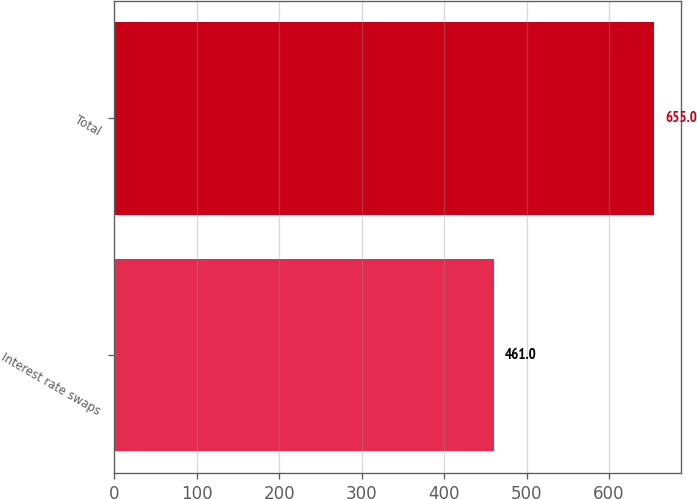Convert chart to OTSL. <chart><loc_0><loc_0><loc_500><loc_500><bar_chart><fcel>Interest rate swaps<fcel>Total<nl><fcel>461<fcel>655<nl></chart> 